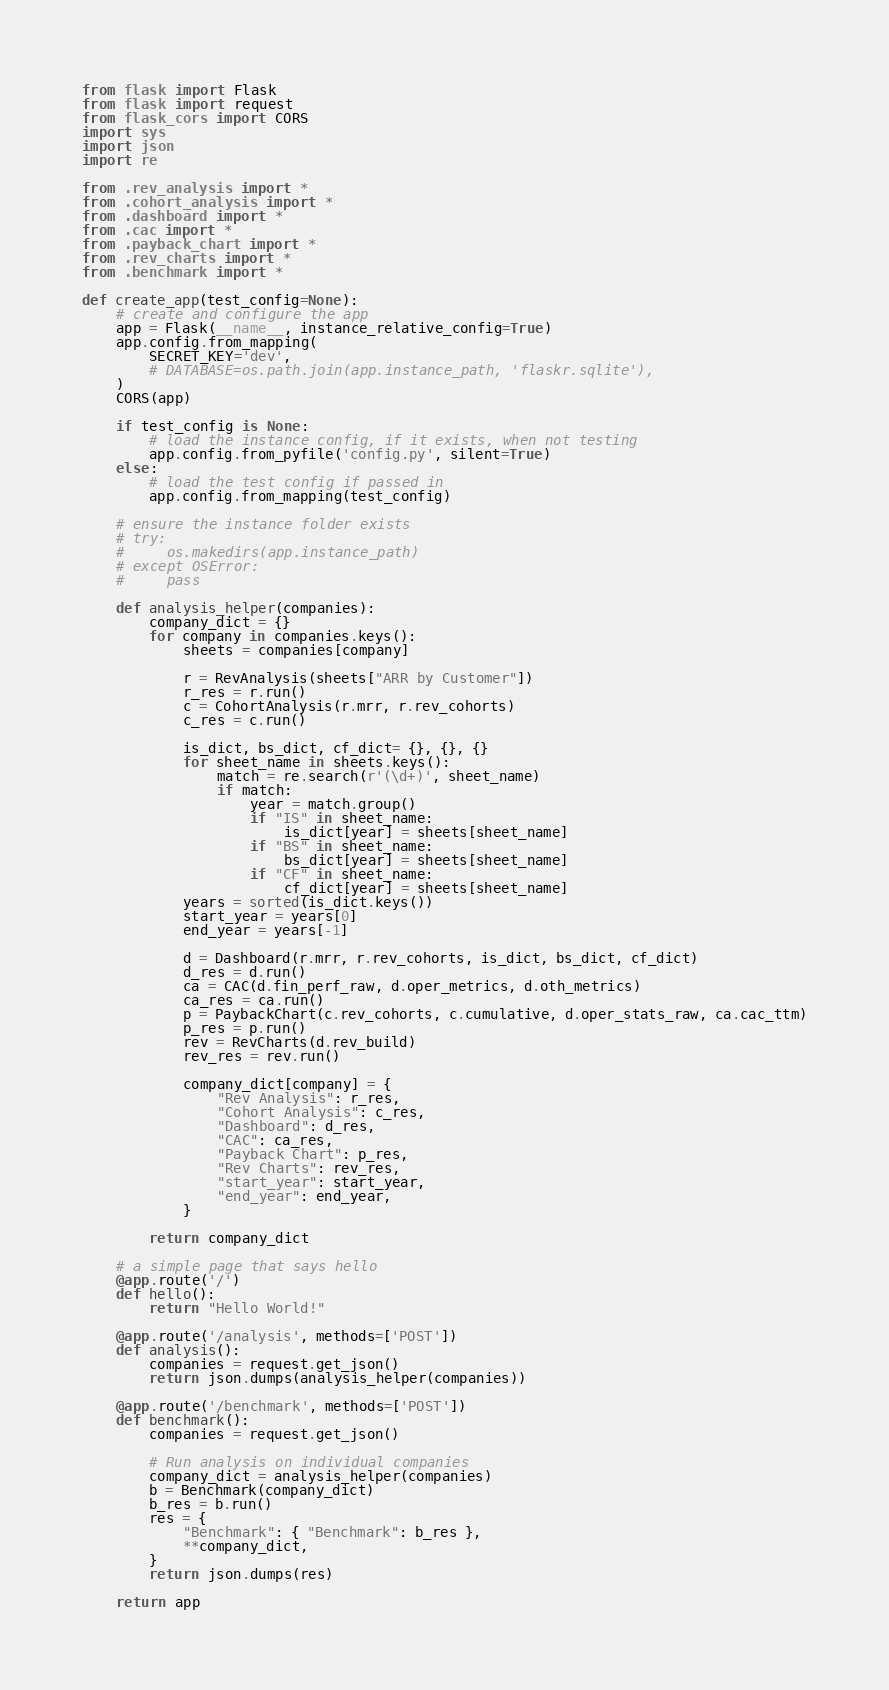Convert code to text. <code><loc_0><loc_0><loc_500><loc_500><_Python_>from flask import Flask
from flask import request
from flask_cors import CORS
import sys
import json
import re

from .rev_analysis import *
from .cohort_analysis import *
from .dashboard import *
from .cac import *
from .payback_chart import *
from .rev_charts import *
from .benchmark import *

def create_app(test_config=None):
    # create and configure the app
    app = Flask(__name__, instance_relative_config=True)
    app.config.from_mapping(
        SECRET_KEY='dev',
        # DATABASE=os.path.join(app.instance_path, 'flaskr.sqlite'),
    )
    CORS(app)

    if test_config is None:
        # load the instance config, if it exists, when not testing
        app.config.from_pyfile('config.py', silent=True)
    else:
        # load the test config if passed in
        app.config.from_mapping(test_config)

    # ensure the instance folder exists
    # try:
    #     os.makedirs(app.instance_path)
    # except OSError:
    #     pass

    def analysis_helper(companies):
        company_dict = {}
        for company in companies.keys():
            sheets = companies[company]

            r = RevAnalysis(sheets["ARR by Customer"])
            r_res = r.run()
            c = CohortAnalysis(r.mrr, r.rev_cohorts)
            c_res = c.run()

            is_dict, bs_dict, cf_dict= {}, {}, {}
            for sheet_name in sheets.keys():
                match = re.search(r'(\d+)', sheet_name)
                if match:
                    year = match.group()
                    if "IS" in sheet_name:
                        is_dict[year] = sheets[sheet_name]
                    if "BS" in sheet_name:
                        bs_dict[year] = sheets[sheet_name]
                    if "CF" in sheet_name:
                        cf_dict[year] = sheets[sheet_name]
            years = sorted(is_dict.keys())
            start_year = years[0]
            end_year = years[-1]

            d = Dashboard(r.mrr, r.rev_cohorts, is_dict, bs_dict, cf_dict)
            d_res = d.run()
            ca = CAC(d.fin_perf_raw, d.oper_metrics, d.oth_metrics)
            ca_res = ca.run()
            p = PaybackChart(c.rev_cohorts, c.cumulative, d.oper_stats_raw, ca.cac_ttm)
            p_res = p.run()
            rev = RevCharts(d.rev_build)
            rev_res = rev.run()

            company_dict[company] = {
                "Rev Analysis": r_res,
                "Cohort Analysis": c_res,
                "Dashboard": d_res,
                "CAC": ca_res,
                "Payback Chart": p_res,
                "Rev Charts": rev_res,
                "start_year": start_year,
                "end_year": end_year,
            }

        return company_dict

    # a simple page that says hello
    @app.route('/')
    def hello():
        return "Hello World!"

    @app.route('/analysis', methods=['POST'])
    def analysis():
        companies = request.get_json()
        return json.dumps(analysis_helper(companies))

    @app.route('/benchmark', methods=['POST'])
    def benchmark():
        companies = request.get_json()

        # Run analysis on individual companies
        company_dict = analysis_helper(companies)
        b = Benchmark(company_dict)
        b_res = b.run()
        res = {
            "Benchmark": { "Benchmark": b_res },
            **company_dict,
        }
        return json.dumps(res)

    return app
</code> 